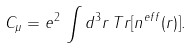Convert formula to latex. <formula><loc_0><loc_0><loc_500><loc_500>C _ { \mu } = e ^ { 2 } \, \int d ^ { 3 } r \, T r [ n ^ { e f f } ( r ) ] .</formula> 